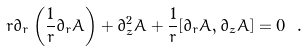Convert formula to latex. <formula><loc_0><loc_0><loc_500><loc_500>r \partial _ { r } \left ( \frac { 1 } { r } \partial _ { r } A \right ) + \partial _ { z } ^ { 2 } A + \frac { 1 } { r } [ \partial _ { r } A , \partial _ { z } A ] = 0 \ .</formula> 